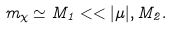<formula> <loc_0><loc_0><loc_500><loc_500>m _ { \chi } \simeq M _ { 1 } < < | \mu | , M _ { 2 } .</formula> 